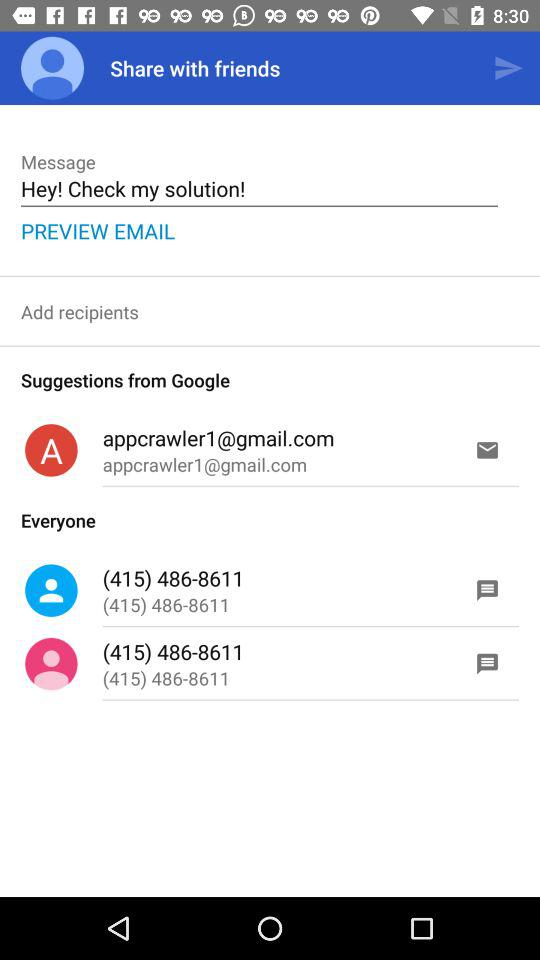What email has been suggested by "Google"? The suggested email is appcrawler1@gmail.com. 